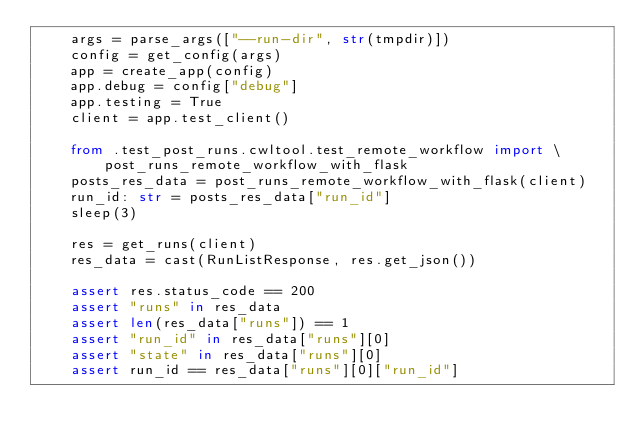<code> <loc_0><loc_0><loc_500><loc_500><_Python_>    args = parse_args(["--run-dir", str(tmpdir)])
    config = get_config(args)
    app = create_app(config)
    app.debug = config["debug"]
    app.testing = True
    client = app.test_client()

    from .test_post_runs.cwltool.test_remote_workflow import \
        post_runs_remote_workflow_with_flask
    posts_res_data = post_runs_remote_workflow_with_flask(client)
    run_id: str = posts_res_data["run_id"]
    sleep(3)

    res = get_runs(client)
    res_data = cast(RunListResponse, res.get_json())

    assert res.status_code == 200
    assert "runs" in res_data
    assert len(res_data["runs"]) == 1
    assert "run_id" in res_data["runs"][0]
    assert "state" in res_data["runs"][0]
    assert run_id == res_data["runs"][0]["run_id"]
</code> 